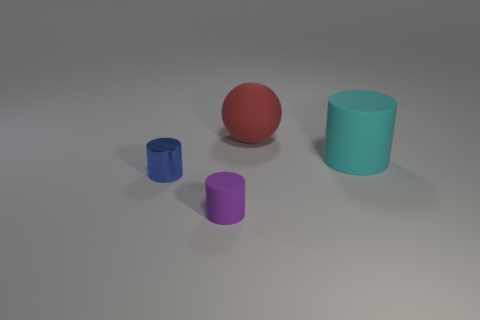Subtract all cyan cylinders. How many cylinders are left? 2 Add 1 tiny shiny cylinders. How many objects exist? 5 Subtract all purple cylinders. How many cylinders are left? 2 Subtract all cylinders. How many objects are left? 1 Subtract 1 cylinders. How many cylinders are left? 2 Subtract all red cubes. How many blue cylinders are left? 1 Subtract 0 red cubes. How many objects are left? 4 Subtract all green cylinders. Subtract all gray blocks. How many cylinders are left? 3 Subtract all tiny red shiny cubes. Subtract all large cyan matte things. How many objects are left? 3 Add 4 tiny rubber things. How many tiny rubber things are left? 5 